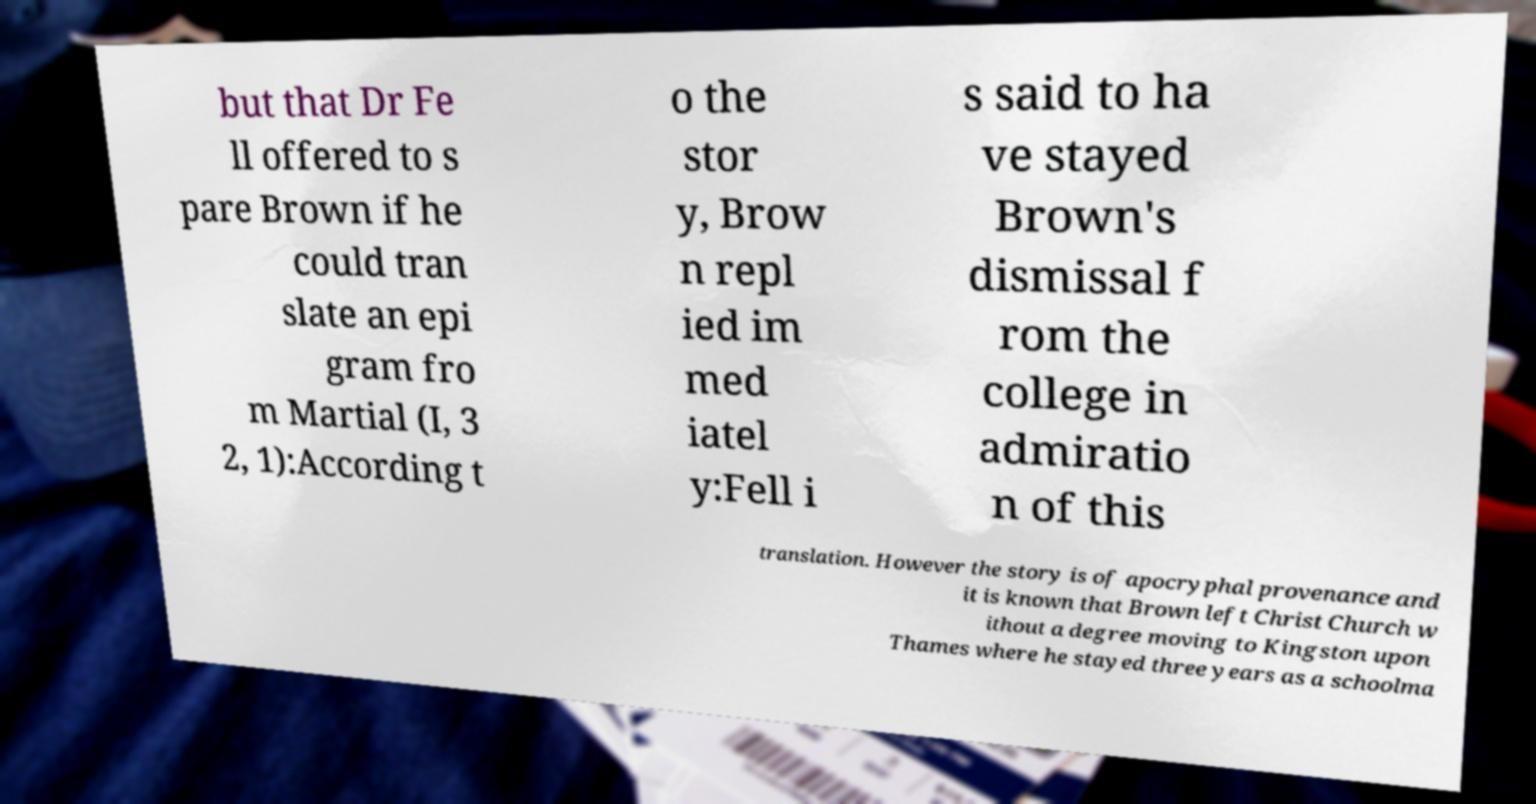For documentation purposes, I need the text within this image transcribed. Could you provide that? but that Dr Fe ll offered to s pare Brown if he could tran slate an epi gram fro m Martial (I, 3 2, 1):According t o the stor y, Brow n repl ied im med iatel y:Fell i s said to ha ve stayed Brown's dismissal f rom the college in admiratio n of this translation. However the story is of apocryphal provenance and it is known that Brown left Christ Church w ithout a degree moving to Kingston upon Thames where he stayed three years as a schoolma 